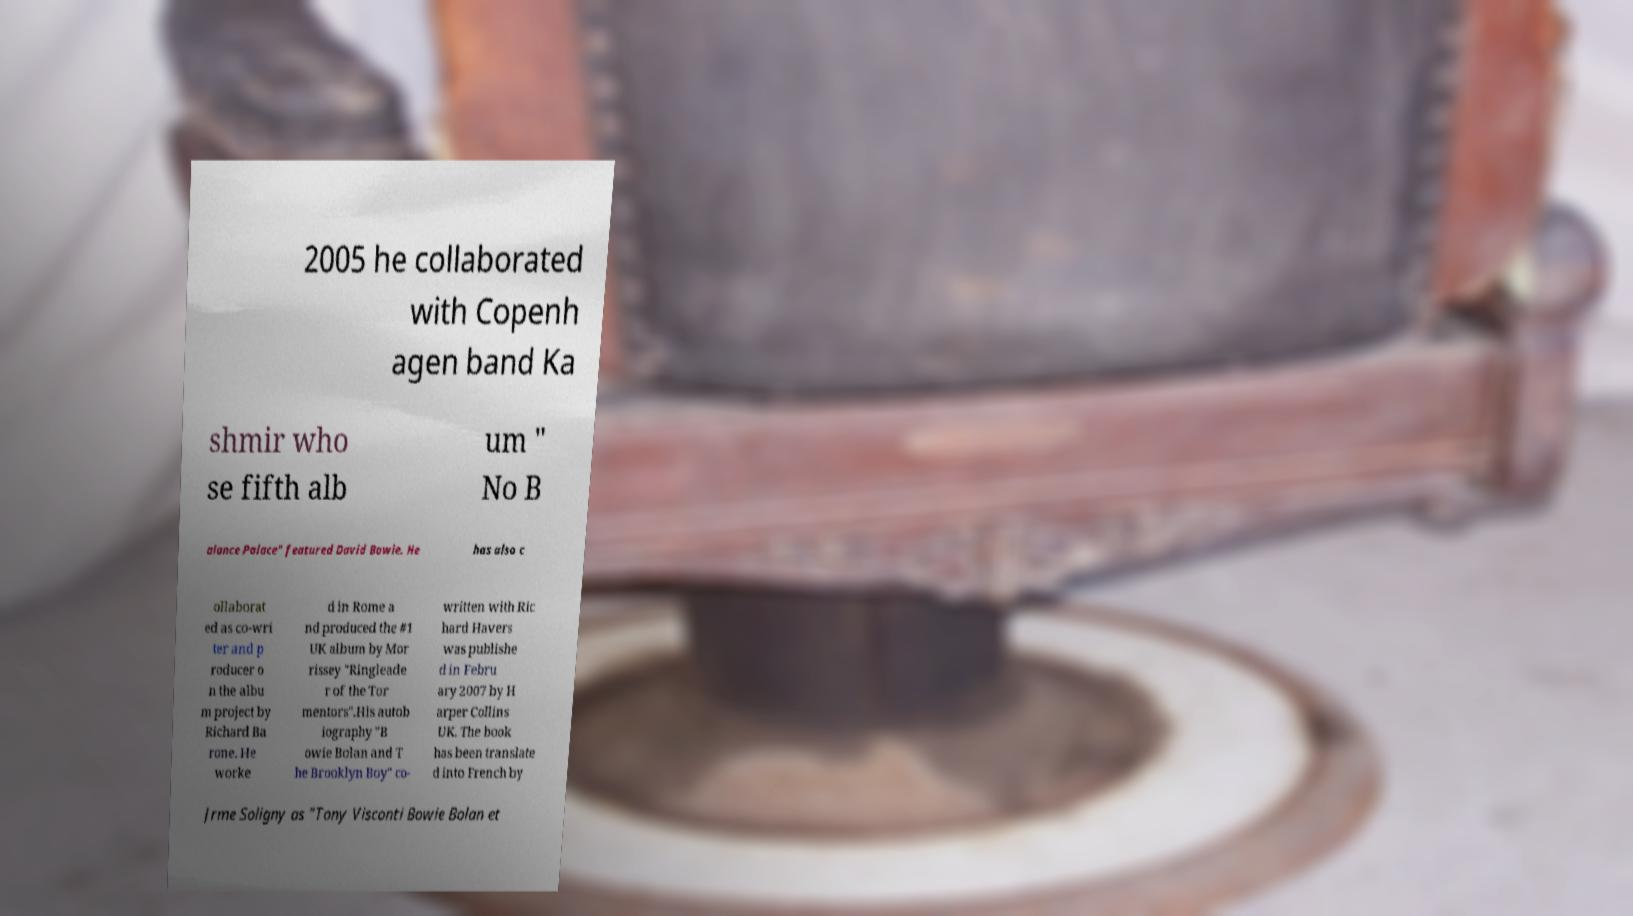What messages or text are displayed in this image? I need them in a readable, typed format. 2005 he collaborated with Copenh agen band Ka shmir who se fifth alb um " No B alance Palace" featured David Bowie. He has also c ollaborat ed as co-wri ter and p roducer o n the albu m project by Richard Ba rone. He worke d in Rome a nd produced the #1 UK album by Mor rissey "Ringleade r of the Tor mentors".His autob iography "B owie Bolan and T he Brooklyn Boy" co- written with Ric hard Havers was publishe d in Febru ary 2007 by H arper Collins UK. The book has been translate d into French by Jrme Soligny as "Tony Visconti Bowie Bolan et 